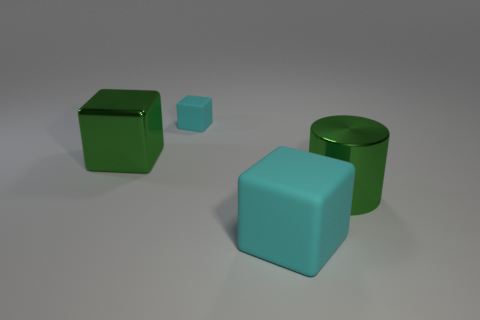Subtract all small cyan cubes. How many cubes are left? 2 Add 1 yellow rubber blocks. How many objects exist? 5 Subtract all cylinders. How many objects are left? 3 Subtract 2 blocks. How many blocks are left? 1 Subtract all cyan blocks. How many blocks are left? 1 Subtract all cyan cylinders. Subtract all big cyan blocks. How many objects are left? 3 Add 3 large cyan cubes. How many large cyan cubes are left? 4 Add 4 green metallic cubes. How many green metallic cubes exist? 5 Subtract 0 purple cubes. How many objects are left? 4 Subtract all red cubes. Subtract all yellow cylinders. How many cubes are left? 3 